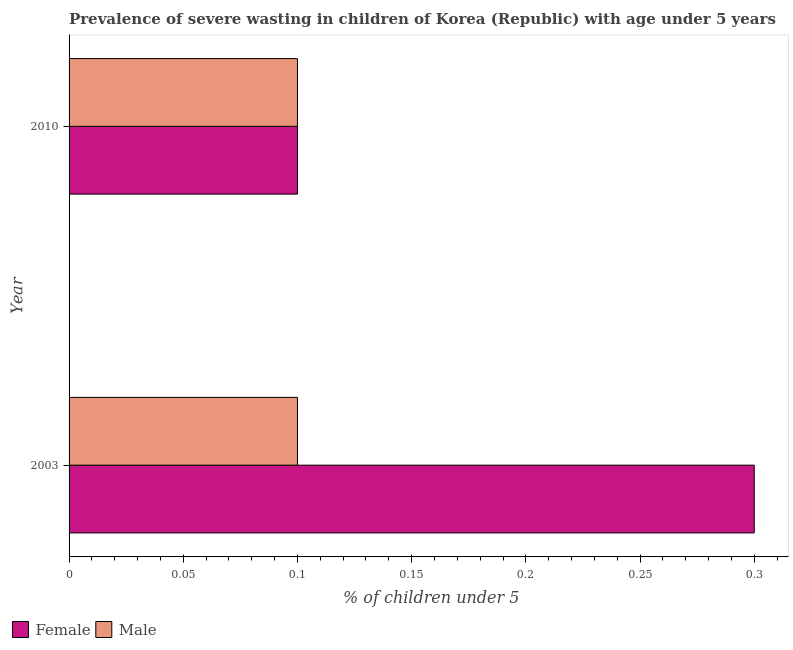How many different coloured bars are there?
Your response must be concise. 2. How many groups of bars are there?
Offer a very short reply. 2. How many bars are there on the 1st tick from the top?
Keep it short and to the point. 2. What is the label of the 1st group of bars from the top?
Keep it short and to the point. 2010. What is the percentage of undernourished male children in 2010?
Your response must be concise. 0.1. Across all years, what is the maximum percentage of undernourished male children?
Provide a short and direct response. 0.1. Across all years, what is the minimum percentage of undernourished male children?
Offer a terse response. 0.1. In which year was the percentage of undernourished male children maximum?
Your answer should be very brief. 2003. In which year was the percentage of undernourished male children minimum?
Provide a short and direct response. 2003. What is the total percentage of undernourished male children in the graph?
Keep it short and to the point. 0.2. What is the difference between the percentage of undernourished male children in 2003 and that in 2010?
Make the answer very short. 0. What is the difference between the percentage of undernourished female children in 2010 and the percentage of undernourished male children in 2003?
Make the answer very short. 0. In the year 2003, what is the difference between the percentage of undernourished female children and percentage of undernourished male children?
Ensure brevity in your answer.  0.2. In how many years, is the percentage of undernourished male children greater than 0.30000000000000004 %?
Make the answer very short. 0. What is the ratio of the percentage of undernourished female children in 2003 to that in 2010?
Provide a short and direct response. 3. Is the percentage of undernourished female children in 2003 less than that in 2010?
Your answer should be compact. No. Is the difference between the percentage of undernourished female children in 2003 and 2010 greater than the difference between the percentage of undernourished male children in 2003 and 2010?
Your answer should be very brief. Yes. In how many years, is the percentage of undernourished female children greater than the average percentage of undernourished female children taken over all years?
Your answer should be compact. 1. What does the 1st bar from the top in 2003 represents?
Give a very brief answer. Male. How many bars are there?
Your answer should be very brief. 4. Are all the bars in the graph horizontal?
Provide a succinct answer. Yes. Does the graph contain grids?
Your answer should be very brief. No. Where does the legend appear in the graph?
Keep it short and to the point. Bottom left. How many legend labels are there?
Ensure brevity in your answer.  2. What is the title of the graph?
Your answer should be compact. Prevalence of severe wasting in children of Korea (Republic) with age under 5 years. What is the label or title of the X-axis?
Make the answer very short.  % of children under 5. What is the label or title of the Y-axis?
Offer a terse response. Year. What is the  % of children under 5 of Female in 2003?
Ensure brevity in your answer.  0.3. What is the  % of children under 5 in Male in 2003?
Make the answer very short. 0.1. What is the  % of children under 5 of Female in 2010?
Keep it short and to the point. 0.1. What is the  % of children under 5 of Male in 2010?
Provide a succinct answer. 0.1. Across all years, what is the maximum  % of children under 5 in Female?
Offer a very short reply. 0.3. Across all years, what is the maximum  % of children under 5 of Male?
Give a very brief answer. 0.1. Across all years, what is the minimum  % of children under 5 of Female?
Offer a very short reply. 0.1. Across all years, what is the minimum  % of children under 5 in Male?
Offer a very short reply. 0.1. What is the total  % of children under 5 in Female in the graph?
Make the answer very short. 0.4. What is the total  % of children under 5 of Male in the graph?
Offer a very short reply. 0.2. What is the difference between the  % of children under 5 of Female in 2003 and the  % of children under 5 of Male in 2010?
Keep it short and to the point. 0.2. What is the average  % of children under 5 in Male per year?
Make the answer very short. 0.1. What is the ratio of the  % of children under 5 of Female in 2003 to that in 2010?
Make the answer very short. 3. What is the difference between the highest and the lowest  % of children under 5 of Female?
Ensure brevity in your answer.  0.2. 